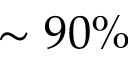Convert formula to latex. <formula><loc_0><loc_0><loc_500><loc_500>\sim 9 0 \%</formula> 